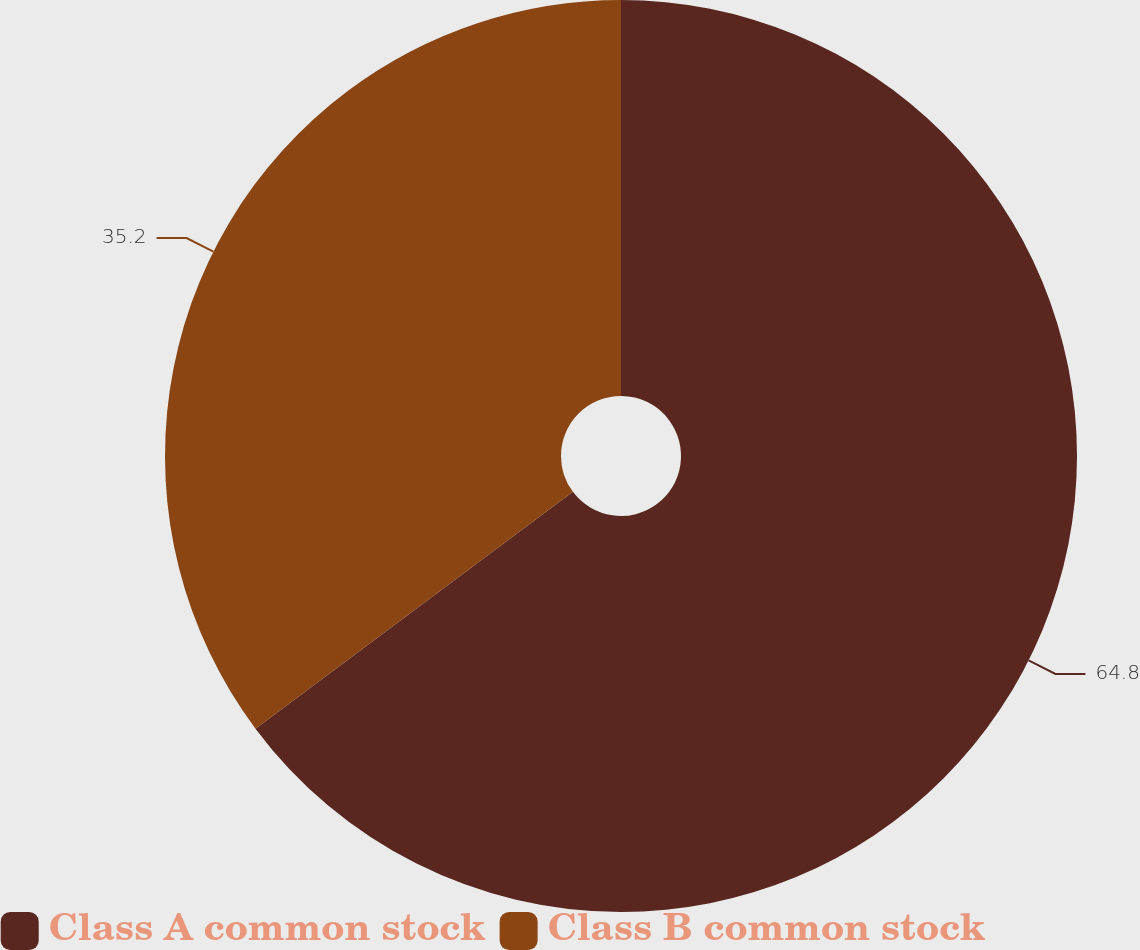Convert chart. <chart><loc_0><loc_0><loc_500><loc_500><pie_chart><fcel>Class A common stock<fcel>Class B common stock<nl><fcel>64.8%<fcel>35.2%<nl></chart> 